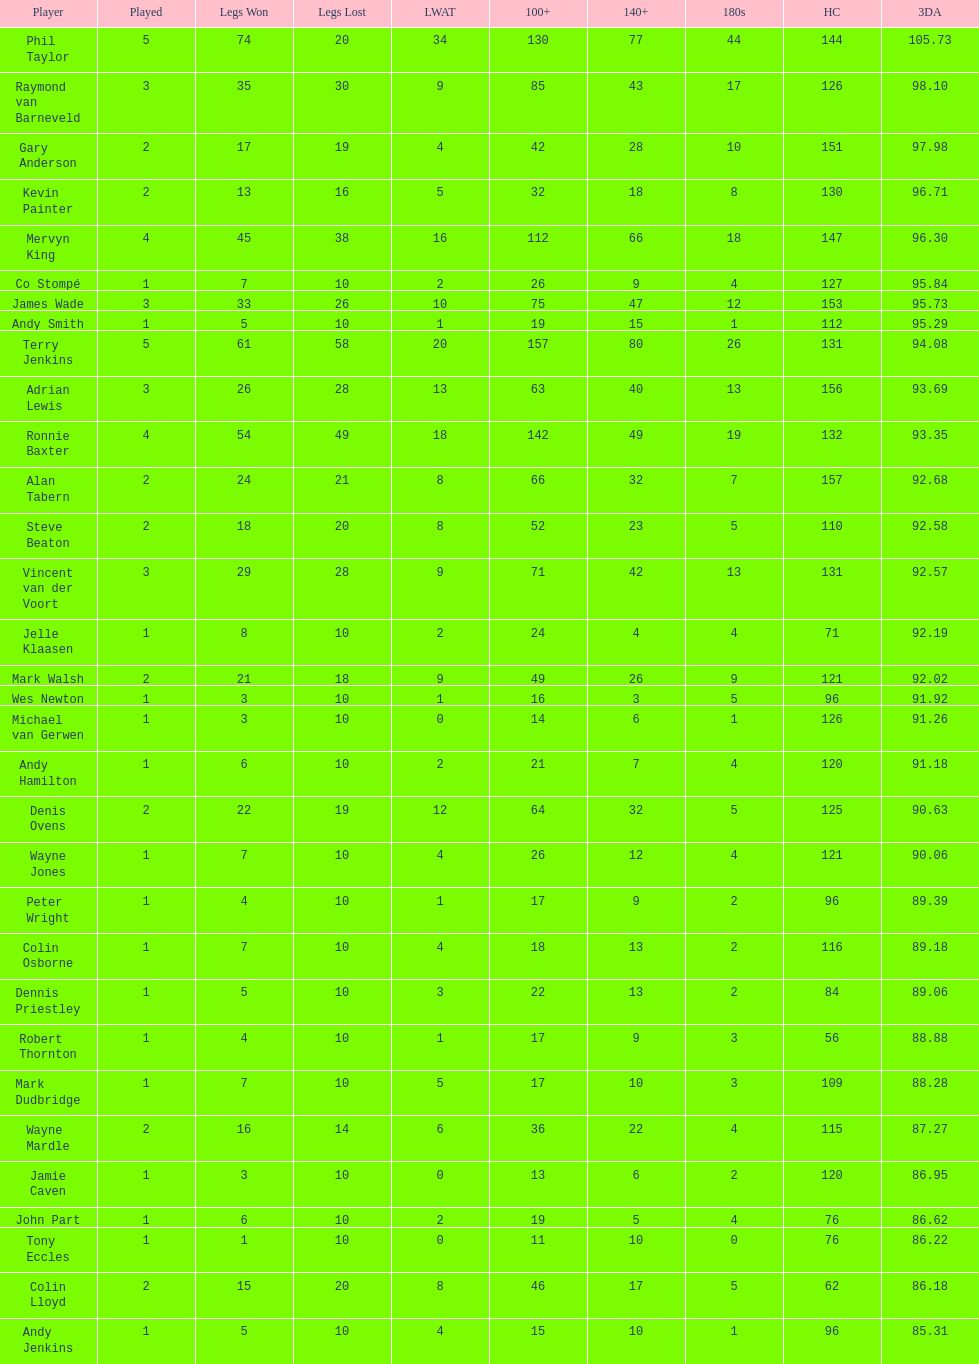Which player lost the least? Co Stompé, Andy Smith, Jelle Klaasen, Wes Newton, Michael van Gerwen, Andy Hamilton, Wayne Jones, Peter Wright, Colin Osborne, Dennis Priestley, Robert Thornton, Mark Dudbridge, Jamie Caven, John Part, Tony Eccles, Andy Jenkins. 